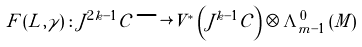<formula> <loc_0><loc_0><loc_500><loc_500>\ F \left ( L , \gamma \right ) \colon J ^ { 2 k - 1 } \mathcal { C } \longrightarrow V ^ { * } \left ( J ^ { k - 1 } \mathcal { C } \right ) \otimes \Lambda _ { m - 1 } ^ { 0 } \left ( M \right )</formula> 